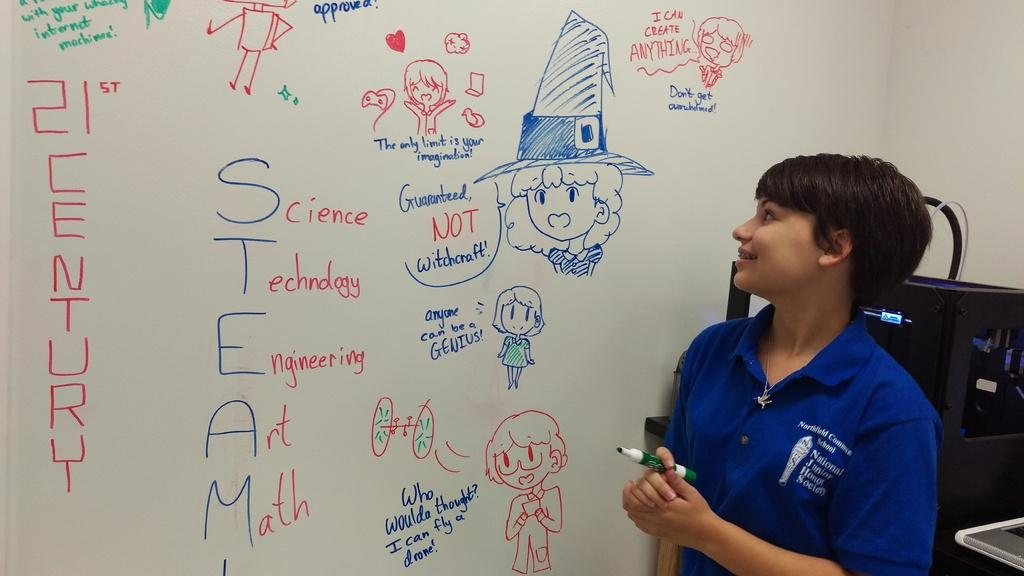<image>
Offer a succinct explanation of the picture presented. A woman standing in front of a whiteboard with 21st Century written on it. 